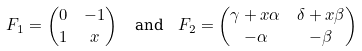Convert formula to latex. <formula><loc_0><loc_0><loc_500><loc_500>F _ { 1 } & = \begin{pmatrix} 0 & - 1 \\ 1 & x \end{pmatrix} \quad \text {and} \quad F _ { 2 } = \begin{pmatrix} \gamma + x \alpha & \delta + x \beta \\ - \alpha & - \beta \end{pmatrix}</formula> 